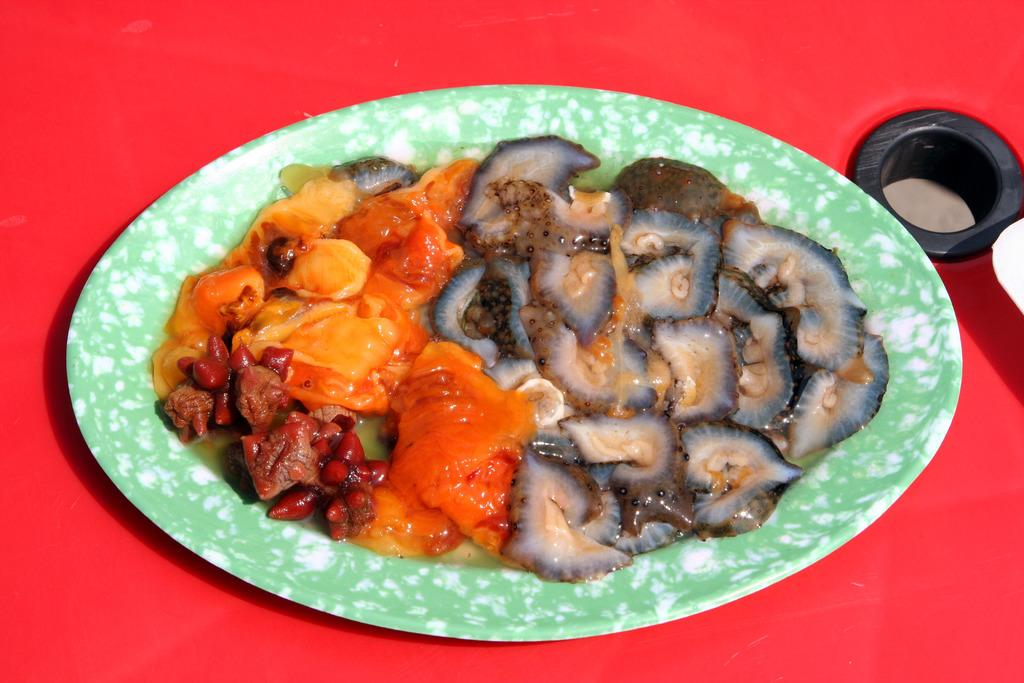What is on the plate that is visible in the image? There is a plate of food items in the image. What is the color of the table in the image? The table is red in color. Can you describe any specific features or details about the image? There is a hole on the right side of the image. What type of sense can be seen on the plate in the image? There is no sense present on the plate in the image. Can you describe the tail of the food item on the plate? There is no tail on the food items on the plate in the image. 